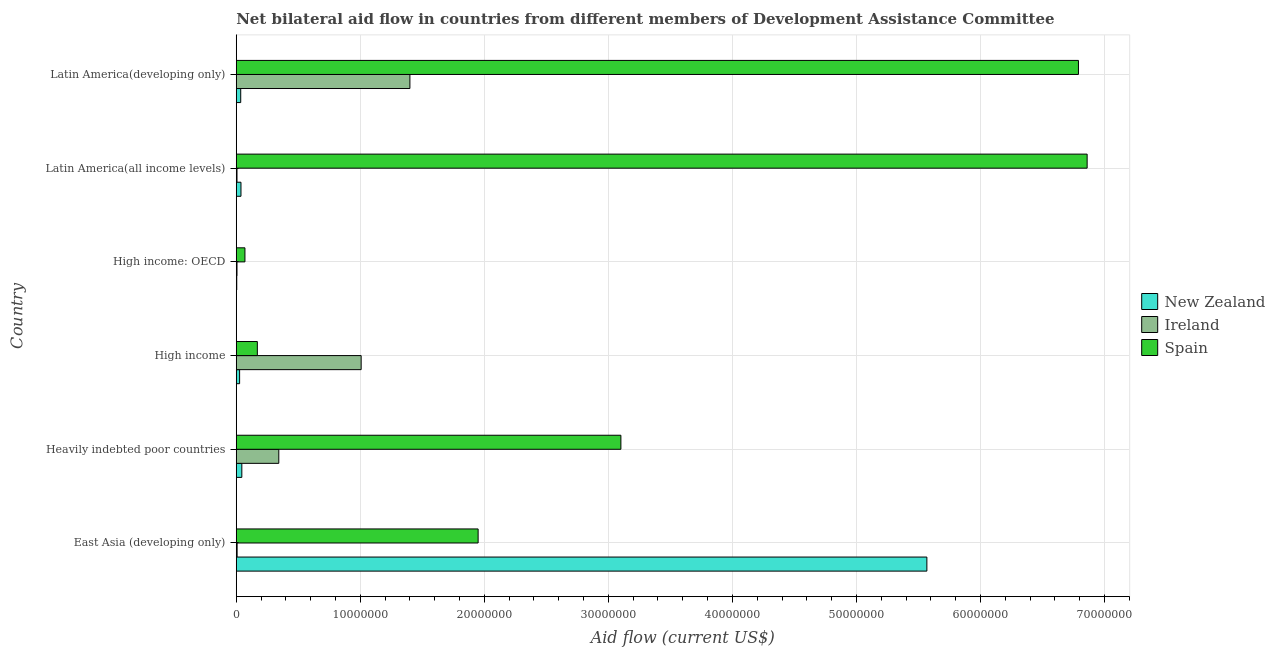Are the number of bars per tick equal to the number of legend labels?
Give a very brief answer. Yes. Are the number of bars on each tick of the Y-axis equal?
Offer a very short reply. Yes. What is the label of the 3rd group of bars from the top?
Make the answer very short. High income: OECD. What is the amount of aid provided by new zealand in East Asia (developing only)?
Offer a terse response. 5.57e+07. Across all countries, what is the maximum amount of aid provided by new zealand?
Provide a short and direct response. 5.57e+07. Across all countries, what is the minimum amount of aid provided by ireland?
Provide a succinct answer. 6.00e+04. In which country was the amount of aid provided by new zealand maximum?
Ensure brevity in your answer.  East Asia (developing only). In which country was the amount of aid provided by new zealand minimum?
Provide a succinct answer. High income: OECD. What is the total amount of aid provided by new zealand in the graph?
Keep it short and to the point. 5.72e+07. What is the difference between the amount of aid provided by ireland in High income and that in Latin America(all income levels)?
Offer a very short reply. 1.00e+07. What is the difference between the amount of aid provided by spain in Latin America(developing only) and the amount of aid provided by new zealand in East Asia (developing only)?
Your response must be concise. 1.22e+07. What is the average amount of aid provided by spain per country?
Ensure brevity in your answer.  3.16e+07. What is the difference between the amount of aid provided by ireland and amount of aid provided by spain in Heavily indebted poor countries?
Keep it short and to the point. -2.76e+07. In how many countries, is the amount of aid provided by new zealand greater than 54000000 US$?
Your answer should be compact. 1. What is the ratio of the amount of aid provided by new zealand in Heavily indebted poor countries to that in High income: OECD?
Offer a very short reply. 11.25. Is the amount of aid provided by new zealand in High income: OECD less than that in Latin America(all income levels)?
Provide a succinct answer. Yes. Is the difference between the amount of aid provided by new zealand in Heavily indebted poor countries and Latin America(all income levels) greater than the difference between the amount of aid provided by spain in Heavily indebted poor countries and Latin America(all income levels)?
Give a very brief answer. Yes. What is the difference between the highest and the lowest amount of aid provided by new zealand?
Your answer should be compact. 5.56e+07. Is the sum of the amount of aid provided by spain in Heavily indebted poor countries and Latin America(developing only) greater than the maximum amount of aid provided by ireland across all countries?
Your answer should be compact. Yes. What does the 3rd bar from the top in Latin America(all income levels) represents?
Provide a succinct answer. New Zealand. What does the 1st bar from the bottom in Latin America(developing only) represents?
Keep it short and to the point. New Zealand. Is it the case that in every country, the sum of the amount of aid provided by new zealand and amount of aid provided by ireland is greater than the amount of aid provided by spain?
Make the answer very short. No. How many bars are there?
Offer a very short reply. 18. Are all the bars in the graph horizontal?
Your answer should be compact. Yes. What is the difference between two consecutive major ticks on the X-axis?
Ensure brevity in your answer.  1.00e+07. Where does the legend appear in the graph?
Provide a short and direct response. Center right. How many legend labels are there?
Your answer should be compact. 3. What is the title of the graph?
Provide a succinct answer. Net bilateral aid flow in countries from different members of Development Assistance Committee. Does "Domestic economy" appear as one of the legend labels in the graph?
Provide a short and direct response. No. What is the label or title of the Y-axis?
Your response must be concise. Country. What is the Aid flow (current US$) of New Zealand in East Asia (developing only)?
Give a very brief answer. 5.57e+07. What is the Aid flow (current US$) of Spain in East Asia (developing only)?
Your answer should be compact. 1.95e+07. What is the Aid flow (current US$) of Ireland in Heavily indebted poor countries?
Offer a terse response. 3.43e+06. What is the Aid flow (current US$) in Spain in Heavily indebted poor countries?
Give a very brief answer. 3.10e+07. What is the Aid flow (current US$) of Ireland in High income?
Your answer should be compact. 1.01e+07. What is the Aid flow (current US$) in Spain in High income?
Give a very brief answer. 1.70e+06. What is the Aid flow (current US$) in New Zealand in High income: OECD?
Ensure brevity in your answer.  4.00e+04. What is the Aid flow (current US$) of Ireland in Latin America(all income levels)?
Give a very brief answer. 6.00e+04. What is the Aid flow (current US$) of Spain in Latin America(all income levels)?
Give a very brief answer. 6.86e+07. What is the Aid flow (current US$) in New Zealand in Latin America(developing only)?
Your response must be concise. 3.60e+05. What is the Aid flow (current US$) in Ireland in Latin America(developing only)?
Keep it short and to the point. 1.40e+07. What is the Aid flow (current US$) of Spain in Latin America(developing only)?
Ensure brevity in your answer.  6.79e+07. Across all countries, what is the maximum Aid flow (current US$) in New Zealand?
Provide a short and direct response. 5.57e+07. Across all countries, what is the maximum Aid flow (current US$) of Ireland?
Offer a terse response. 1.40e+07. Across all countries, what is the maximum Aid flow (current US$) in Spain?
Keep it short and to the point. 6.86e+07. Across all countries, what is the minimum Aid flow (current US$) of Spain?
Keep it short and to the point. 7.00e+05. What is the total Aid flow (current US$) in New Zealand in the graph?
Your answer should be compact. 5.72e+07. What is the total Aid flow (current US$) of Ireland in the graph?
Make the answer very short. 2.77e+07. What is the total Aid flow (current US$) in Spain in the graph?
Offer a very short reply. 1.89e+08. What is the difference between the Aid flow (current US$) of New Zealand in East Asia (developing only) and that in Heavily indebted poor countries?
Provide a succinct answer. 5.52e+07. What is the difference between the Aid flow (current US$) of Ireland in East Asia (developing only) and that in Heavily indebted poor countries?
Provide a short and direct response. -3.36e+06. What is the difference between the Aid flow (current US$) of Spain in East Asia (developing only) and that in Heavily indebted poor countries?
Your response must be concise. -1.15e+07. What is the difference between the Aid flow (current US$) in New Zealand in East Asia (developing only) and that in High income?
Your answer should be compact. 5.54e+07. What is the difference between the Aid flow (current US$) in Ireland in East Asia (developing only) and that in High income?
Keep it short and to the point. -1.00e+07. What is the difference between the Aid flow (current US$) of Spain in East Asia (developing only) and that in High income?
Your response must be concise. 1.78e+07. What is the difference between the Aid flow (current US$) in New Zealand in East Asia (developing only) and that in High income: OECD?
Your answer should be very brief. 5.56e+07. What is the difference between the Aid flow (current US$) in Ireland in East Asia (developing only) and that in High income: OECD?
Your answer should be compact. 10000. What is the difference between the Aid flow (current US$) of Spain in East Asia (developing only) and that in High income: OECD?
Give a very brief answer. 1.88e+07. What is the difference between the Aid flow (current US$) of New Zealand in East Asia (developing only) and that in Latin America(all income levels)?
Keep it short and to the point. 5.53e+07. What is the difference between the Aid flow (current US$) of Spain in East Asia (developing only) and that in Latin America(all income levels)?
Offer a very short reply. -4.91e+07. What is the difference between the Aid flow (current US$) in New Zealand in East Asia (developing only) and that in Latin America(developing only)?
Your answer should be compact. 5.53e+07. What is the difference between the Aid flow (current US$) of Ireland in East Asia (developing only) and that in Latin America(developing only)?
Offer a very short reply. -1.39e+07. What is the difference between the Aid flow (current US$) of Spain in East Asia (developing only) and that in Latin America(developing only)?
Keep it short and to the point. -4.84e+07. What is the difference between the Aid flow (current US$) of New Zealand in Heavily indebted poor countries and that in High income?
Make the answer very short. 1.80e+05. What is the difference between the Aid flow (current US$) of Ireland in Heavily indebted poor countries and that in High income?
Ensure brevity in your answer.  -6.64e+06. What is the difference between the Aid flow (current US$) in Spain in Heavily indebted poor countries and that in High income?
Your answer should be compact. 2.93e+07. What is the difference between the Aid flow (current US$) of Ireland in Heavily indebted poor countries and that in High income: OECD?
Provide a short and direct response. 3.37e+06. What is the difference between the Aid flow (current US$) of Spain in Heavily indebted poor countries and that in High income: OECD?
Offer a very short reply. 3.03e+07. What is the difference between the Aid flow (current US$) of Ireland in Heavily indebted poor countries and that in Latin America(all income levels)?
Make the answer very short. 3.37e+06. What is the difference between the Aid flow (current US$) of Spain in Heavily indebted poor countries and that in Latin America(all income levels)?
Provide a short and direct response. -3.76e+07. What is the difference between the Aid flow (current US$) in New Zealand in Heavily indebted poor countries and that in Latin America(developing only)?
Provide a succinct answer. 9.00e+04. What is the difference between the Aid flow (current US$) of Ireland in Heavily indebted poor countries and that in Latin America(developing only)?
Offer a terse response. -1.06e+07. What is the difference between the Aid flow (current US$) of Spain in Heavily indebted poor countries and that in Latin America(developing only)?
Ensure brevity in your answer.  -3.69e+07. What is the difference between the Aid flow (current US$) in New Zealand in High income and that in High income: OECD?
Keep it short and to the point. 2.30e+05. What is the difference between the Aid flow (current US$) of Ireland in High income and that in High income: OECD?
Provide a short and direct response. 1.00e+07. What is the difference between the Aid flow (current US$) in New Zealand in High income and that in Latin America(all income levels)?
Your answer should be compact. -1.10e+05. What is the difference between the Aid flow (current US$) of Ireland in High income and that in Latin America(all income levels)?
Your response must be concise. 1.00e+07. What is the difference between the Aid flow (current US$) of Spain in High income and that in Latin America(all income levels)?
Offer a very short reply. -6.69e+07. What is the difference between the Aid flow (current US$) of Ireland in High income and that in Latin America(developing only)?
Your answer should be very brief. -3.93e+06. What is the difference between the Aid flow (current US$) of Spain in High income and that in Latin America(developing only)?
Offer a very short reply. -6.62e+07. What is the difference between the Aid flow (current US$) of Spain in High income: OECD and that in Latin America(all income levels)?
Offer a very short reply. -6.79e+07. What is the difference between the Aid flow (current US$) of New Zealand in High income: OECD and that in Latin America(developing only)?
Provide a succinct answer. -3.20e+05. What is the difference between the Aid flow (current US$) in Ireland in High income: OECD and that in Latin America(developing only)?
Give a very brief answer. -1.39e+07. What is the difference between the Aid flow (current US$) of Spain in High income: OECD and that in Latin America(developing only)?
Give a very brief answer. -6.72e+07. What is the difference between the Aid flow (current US$) in New Zealand in Latin America(all income levels) and that in Latin America(developing only)?
Give a very brief answer. 2.00e+04. What is the difference between the Aid flow (current US$) in Ireland in Latin America(all income levels) and that in Latin America(developing only)?
Make the answer very short. -1.39e+07. What is the difference between the Aid flow (current US$) of Spain in Latin America(all income levels) and that in Latin America(developing only)?
Give a very brief answer. 7.00e+05. What is the difference between the Aid flow (current US$) in New Zealand in East Asia (developing only) and the Aid flow (current US$) in Ireland in Heavily indebted poor countries?
Provide a succinct answer. 5.22e+07. What is the difference between the Aid flow (current US$) in New Zealand in East Asia (developing only) and the Aid flow (current US$) in Spain in Heavily indebted poor countries?
Offer a very short reply. 2.47e+07. What is the difference between the Aid flow (current US$) in Ireland in East Asia (developing only) and the Aid flow (current US$) in Spain in Heavily indebted poor countries?
Your answer should be compact. -3.09e+07. What is the difference between the Aid flow (current US$) in New Zealand in East Asia (developing only) and the Aid flow (current US$) in Ireland in High income?
Provide a short and direct response. 4.56e+07. What is the difference between the Aid flow (current US$) in New Zealand in East Asia (developing only) and the Aid flow (current US$) in Spain in High income?
Offer a terse response. 5.40e+07. What is the difference between the Aid flow (current US$) in Ireland in East Asia (developing only) and the Aid flow (current US$) in Spain in High income?
Ensure brevity in your answer.  -1.63e+06. What is the difference between the Aid flow (current US$) of New Zealand in East Asia (developing only) and the Aid flow (current US$) of Ireland in High income: OECD?
Keep it short and to the point. 5.56e+07. What is the difference between the Aid flow (current US$) in New Zealand in East Asia (developing only) and the Aid flow (current US$) in Spain in High income: OECD?
Make the answer very short. 5.50e+07. What is the difference between the Aid flow (current US$) in Ireland in East Asia (developing only) and the Aid flow (current US$) in Spain in High income: OECD?
Give a very brief answer. -6.30e+05. What is the difference between the Aid flow (current US$) in New Zealand in East Asia (developing only) and the Aid flow (current US$) in Ireland in Latin America(all income levels)?
Offer a terse response. 5.56e+07. What is the difference between the Aid flow (current US$) of New Zealand in East Asia (developing only) and the Aid flow (current US$) of Spain in Latin America(all income levels)?
Your response must be concise. -1.29e+07. What is the difference between the Aid flow (current US$) of Ireland in East Asia (developing only) and the Aid flow (current US$) of Spain in Latin America(all income levels)?
Offer a terse response. -6.85e+07. What is the difference between the Aid flow (current US$) in New Zealand in East Asia (developing only) and the Aid flow (current US$) in Ireland in Latin America(developing only)?
Make the answer very short. 4.17e+07. What is the difference between the Aid flow (current US$) in New Zealand in East Asia (developing only) and the Aid flow (current US$) in Spain in Latin America(developing only)?
Provide a succinct answer. -1.22e+07. What is the difference between the Aid flow (current US$) in Ireland in East Asia (developing only) and the Aid flow (current US$) in Spain in Latin America(developing only)?
Provide a succinct answer. -6.78e+07. What is the difference between the Aid flow (current US$) of New Zealand in Heavily indebted poor countries and the Aid flow (current US$) of Ireland in High income?
Offer a terse response. -9.62e+06. What is the difference between the Aid flow (current US$) of New Zealand in Heavily indebted poor countries and the Aid flow (current US$) of Spain in High income?
Your answer should be very brief. -1.25e+06. What is the difference between the Aid flow (current US$) in Ireland in Heavily indebted poor countries and the Aid flow (current US$) in Spain in High income?
Offer a very short reply. 1.73e+06. What is the difference between the Aid flow (current US$) in Ireland in Heavily indebted poor countries and the Aid flow (current US$) in Spain in High income: OECD?
Make the answer very short. 2.73e+06. What is the difference between the Aid flow (current US$) of New Zealand in Heavily indebted poor countries and the Aid flow (current US$) of Spain in Latin America(all income levels)?
Make the answer very short. -6.82e+07. What is the difference between the Aid flow (current US$) in Ireland in Heavily indebted poor countries and the Aid flow (current US$) in Spain in Latin America(all income levels)?
Offer a terse response. -6.52e+07. What is the difference between the Aid flow (current US$) in New Zealand in Heavily indebted poor countries and the Aid flow (current US$) in Ireland in Latin America(developing only)?
Offer a very short reply. -1.36e+07. What is the difference between the Aid flow (current US$) in New Zealand in Heavily indebted poor countries and the Aid flow (current US$) in Spain in Latin America(developing only)?
Keep it short and to the point. -6.74e+07. What is the difference between the Aid flow (current US$) in Ireland in Heavily indebted poor countries and the Aid flow (current US$) in Spain in Latin America(developing only)?
Your response must be concise. -6.45e+07. What is the difference between the Aid flow (current US$) of New Zealand in High income and the Aid flow (current US$) of Ireland in High income: OECD?
Your response must be concise. 2.10e+05. What is the difference between the Aid flow (current US$) of New Zealand in High income and the Aid flow (current US$) of Spain in High income: OECD?
Offer a very short reply. -4.30e+05. What is the difference between the Aid flow (current US$) in Ireland in High income and the Aid flow (current US$) in Spain in High income: OECD?
Provide a short and direct response. 9.37e+06. What is the difference between the Aid flow (current US$) in New Zealand in High income and the Aid flow (current US$) in Ireland in Latin America(all income levels)?
Your answer should be very brief. 2.10e+05. What is the difference between the Aid flow (current US$) of New Zealand in High income and the Aid flow (current US$) of Spain in Latin America(all income levels)?
Give a very brief answer. -6.83e+07. What is the difference between the Aid flow (current US$) of Ireland in High income and the Aid flow (current US$) of Spain in Latin America(all income levels)?
Your answer should be very brief. -5.85e+07. What is the difference between the Aid flow (current US$) in New Zealand in High income and the Aid flow (current US$) in Ireland in Latin America(developing only)?
Your answer should be compact. -1.37e+07. What is the difference between the Aid flow (current US$) in New Zealand in High income and the Aid flow (current US$) in Spain in Latin America(developing only)?
Your answer should be very brief. -6.76e+07. What is the difference between the Aid flow (current US$) in Ireland in High income and the Aid flow (current US$) in Spain in Latin America(developing only)?
Provide a succinct answer. -5.78e+07. What is the difference between the Aid flow (current US$) of New Zealand in High income: OECD and the Aid flow (current US$) of Spain in Latin America(all income levels)?
Make the answer very short. -6.86e+07. What is the difference between the Aid flow (current US$) in Ireland in High income: OECD and the Aid flow (current US$) in Spain in Latin America(all income levels)?
Your response must be concise. -6.85e+07. What is the difference between the Aid flow (current US$) of New Zealand in High income: OECD and the Aid flow (current US$) of Ireland in Latin America(developing only)?
Provide a succinct answer. -1.40e+07. What is the difference between the Aid flow (current US$) of New Zealand in High income: OECD and the Aid flow (current US$) of Spain in Latin America(developing only)?
Give a very brief answer. -6.79e+07. What is the difference between the Aid flow (current US$) of Ireland in High income: OECD and the Aid flow (current US$) of Spain in Latin America(developing only)?
Your response must be concise. -6.78e+07. What is the difference between the Aid flow (current US$) of New Zealand in Latin America(all income levels) and the Aid flow (current US$) of Ireland in Latin America(developing only)?
Provide a short and direct response. -1.36e+07. What is the difference between the Aid flow (current US$) of New Zealand in Latin America(all income levels) and the Aid flow (current US$) of Spain in Latin America(developing only)?
Provide a succinct answer. -6.75e+07. What is the difference between the Aid flow (current US$) of Ireland in Latin America(all income levels) and the Aid flow (current US$) of Spain in Latin America(developing only)?
Offer a very short reply. -6.78e+07. What is the average Aid flow (current US$) of New Zealand per country?
Make the answer very short. 9.53e+06. What is the average Aid flow (current US$) of Ireland per country?
Keep it short and to the point. 4.62e+06. What is the average Aid flow (current US$) in Spain per country?
Your answer should be very brief. 3.16e+07. What is the difference between the Aid flow (current US$) in New Zealand and Aid flow (current US$) in Ireland in East Asia (developing only)?
Provide a succinct answer. 5.56e+07. What is the difference between the Aid flow (current US$) in New Zealand and Aid flow (current US$) in Spain in East Asia (developing only)?
Provide a short and direct response. 3.62e+07. What is the difference between the Aid flow (current US$) of Ireland and Aid flow (current US$) of Spain in East Asia (developing only)?
Give a very brief answer. -1.94e+07. What is the difference between the Aid flow (current US$) in New Zealand and Aid flow (current US$) in Ireland in Heavily indebted poor countries?
Give a very brief answer. -2.98e+06. What is the difference between the Aid flow (current US$) of New Zealand and Aid flow (current US$) of Spain in Heavily indebted poor countries?
Keep it short and to the point. -3.06e+07. What is the difference between the Aid flow (current US$) in Ireland and Aid flow (current US$) in Spain in Heavily indebted poor countries?
Make the answer very short. -2.76e+07. What is the difference between the Aid flow (current US$) in New Zealand and Aid flow (current US$) in Ireland in High income?
Ensure brevity in your answer.  -9.80e+06. What is the difference between the Aid flow (current US$) in New Zealand and Aid flow (current US$) in Spain in High income?
Give a very brief answer. -1.43e+06. What is the difference between the Aid flow (current US$) in Ireland and Aid flow (current US$) in Spain in High income?
Your answer should be compact. 8.37e+06. What is the difference between the Aid flow (current US$) of New Zealand and Aid flow (current US$) of Ireland in High income: OECD?
Offer a terse response. -2.00e+04. What is the difference between the Aid flow (current US$) in New Zealand and Aid flow (current US$) in Spain in High income: OECD?
Keep it short and to the point. -6.60e+05. What is the difference between the Aid flow (current US$) of Ireland and Aid flow (current US$) of Spain in High income: OECD?
Keep it short and to the point. -6.40e+05. What is the difference between the Aid flow (current US$) of New Zealand and Aid flow (current US$) of Spain in Latin America(all income levels)?
Ensure brevity in your answer.  -6.82e+07. What is the difference between the Aid flow (current US$) in Ireland and Aid flow (current US$) in Spain in Latin America(all income levels)?
Provide a succinct answer. -6.85e+07. What is the difference between the Aid flow (current US$) in New Zealand and Aid flow (current US$) in Ireland in Latin America(developing only)?
Your answer should be very brief. -1.36e+07. What is the difference between the Aid flow (current US$) in New Zealand and Aid flow (current US$) in Spain in Latin America(developing only)?
Offer a terse response. -6.75e+07. What is the difference between the Aid flow (current US$) of Ireland and Aid flow (current US$) of Spain in Latin America(developing only)?
Offer a terse response. -5.39e+07. What is the ratio of the Aid flow (current US$) of New Zealand in East Asia (developing only) to that in Heavily indebted poor countries?
Offer a very short reply. 123.73. What is the ratio of the Aid flow (current US$) in Ireland in East Asia (developing only) to that in Heavily indebted poor countries?
Your response must be concise. 0.02. What is the ratio of the Aid flow (current US$) in Spain in East Asia (developing only) to that in Heavily indebted poor countries?
Keep it short and to the point. 0.63. What is the ratio of the Aid flow (current US$) in New Zealand in East Asia (developing only) to that in High income?
Offer a very short reply. 206.22. What is the ratio of the Aid flow (current US$) of Ireland in East Asia (developing only) to that in High income?
Give a very brief answer. 0.01. What is the ratio of the Aid flow (current US$) of Spain in East Asia (developing only) to that in High income?
Ensure brevity in your answer.  11.47. What is the ratio of the Aid flow (current US$) of New Zealand in East Asia (developing only) to that in High income: OECD?
Your response must be concise. 1392. What is the ratio of the Aid flow (current US$) of Spain in East Asia (developing only) to that in High income: OECD?
Offer a terse response. 27.86. What is the ratio of the Aid flow (current US$) of New Zealand in East Asia (developing only) to that in Latin America(all income levels)?
Ensure brevity in your answer.  146.53. What is the ratio of the Aid flow (current US$) of Spain in East Asia (developing only) to that in Latin America(all income levels)?
Offer a very short reply. 0.28. What is the ratio of the Aid flow (current US$) in New Zealand in East Asia (developing only) to that in Latin America(developing only)?
Offer a very short reply. 154.67. What is the ratio of the Aid flow (current US$) of Ireland in East Asia (developing only) to that in Latin America(developing only)?
Your response must be concise. 0.01. What is the ratio of the Aid flow (current US$) of Spain in East Asia (developing only) to that in Latin America(developing only)?
Give a very brief answer. 0.29. What is the ratio of the Aid flow (current US$) of Ireland in Heavily indebted poor countries to that in High income?
Your answer should be compact. 0.34. What is the ratio of the Aid flow (current US$) of Spain in Heavily indebted poor countries to that in High income?
Your answer should be very brief. 18.24. What is the ratio of the Aid flow (current US$) in New Zealand in Heavily indebted poor countries to that in High income: OECD?
Your answer should be very brief. 11.25. What is the ratio of the Aid flow (current US$) of Ireland in Heavily indebted poor countries to that in High income: OECD?
Give a very brief answer. 57.17. What is the ratio of the Aid flow (current US$) of Spain in Heavily indebted poor countries to that in High income: OECD?
Give a very brief answer. 44.3. What is the ratio of the Aid flow (current US$) of New Zealand in Heavily indebted poor countries to that in Latin America(all income levels)?
Ensure brevity in your answer.  1.18. What is the ratio of the Aid flow (current US$) in Ireland in Heavily indebted poor countries to that in Latin America(all income levels)?
Offer a very short reply. 57.17. What is the ratio of the Aid flow (current US$) of Spain in Heavily indebted poor countries to that in Latin America(all income levels)?
Ensure brevity in your answer.  0.45. What is the ratio of the Aid flow (current US$) of Ireland in Heavily indebted poor countries to that in Latin America(developing only)?
Offer a very short reply. 0.24. What is the ratio of the Aid flow (current US$) of Spain in Heavily indebted poor countries to that in Latin America(developing only)?
Give a very brief answer. 0.46. What is the ratio of the Aid flow (current US$) in New Zealand in High income to that in High income: OECD?
Offer a very short reply. 6.75. What is the ratio of the Aid flow (current US$) in Ireland in High income to that in High income: OECD?
Provide a succinct answer. 167.83. What is the ratio of the Aid flow (current US$) of Spain in High income to that in High income: OECD?
Give a very brief answer. 2.43. What is the ratio of the Aid flow (current US$) of New Zealand in High income to that in Latin America(all income levels)?
Keep it short and to the point. 0.71. What is the ratio of the Aid flow (current US$) in Ireland in High income to that in Latin America(all income levels)?
Provide a succinct answer. 167.83. What is the ratio of the Aid flow (current US$) of Spain in High income to that in Latin America(all income levels)?
Offer a terse response. 0.02. What is the ratio of the Aid flow (current US$) of New Zealand in High income to that in Latin America(developing only)?
Your answer should be compact. 0.75. What is the ratio of the Aid flow (current US$) in Ireland in High income to that in Latin America(developing only)?
Your answer should be compact. 0.72. What is the ratio of the Aid flow (current US$) in Spain in High income to that in Latin America(developing only)?
Your answer should be very brief. 0.03. What is the ratio of the Aid flow (current US$) in New Zealand in High income: OECD to that in Latin America(all income levels)?
Offer a very short reply. 0.11. What is the ratio of the Aid flow (current US$) in Ireland in High income: OECD to that in Latin America(all income levels)?
Provide a succinct answer. 1. What is the ratio of the Aid flow (current US$) in Spain in High income: OECD to that in Latin America(all income levels)?
Offer a very short reply. 0.01. What is the ratio of the Aid flow (current US$) in New Zealand in High income: OECD to that in Latin America(developing only)?
Provide a succinct answer. 0.11. What is the ratio of the Aid flow (current US$) in Ireland in High income: OECD to that in Latin America(developing only)?
Your answer should be compact. 0. What is the ratio of the Aid flow (current US$) of Spain in High income: OECD to that in Latin America(developing only)?
Your response must be concise. 0.01. What is the ratio of the Aid flow (current US$) in New Zealand in Latin America(all income levels) to that in Latin America(developing only)?
Your response must be concise. 1.06. What is the ratio of the Aid flow (current US$) of Ireland in Latin America(all income levels) to that in Latin America(developing only)?
Provide a short and direct response. 0. What is the ratio of the Aid flow (current US$) of Spain in Latin America(all income levels) to that in Latin America(developing only)?
Make the answer very short. 1.01. What is the difference between the highest and the second highest Aid flow (current US$) in New Zealand?
Offer a very short reply. 5.52e+07. What is the difference between the highest and the second highest Aid flow (current US$) of Ireland?
Ensure brevity in your answer.  3.93e+06. What is the difference between the highest and the lowest Aid flow (current US$) in New Zealand?
Provide a short and direct response. 5.56e+07. What is the difference between the highest and the lowest Aid flow (current US$) in Ireland?
Your response must be concise. 1.39e+07. What is the difference between the highest and the lowest Aid flow (current US$) of Spain?
Make the answer very short. 6.79e+07. 